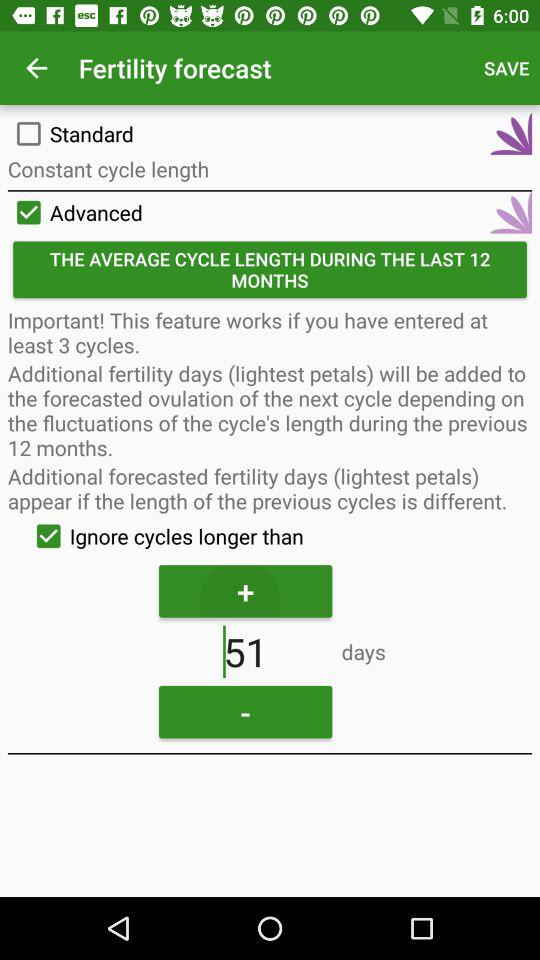What is the status of "Standard"? The status is "off". 